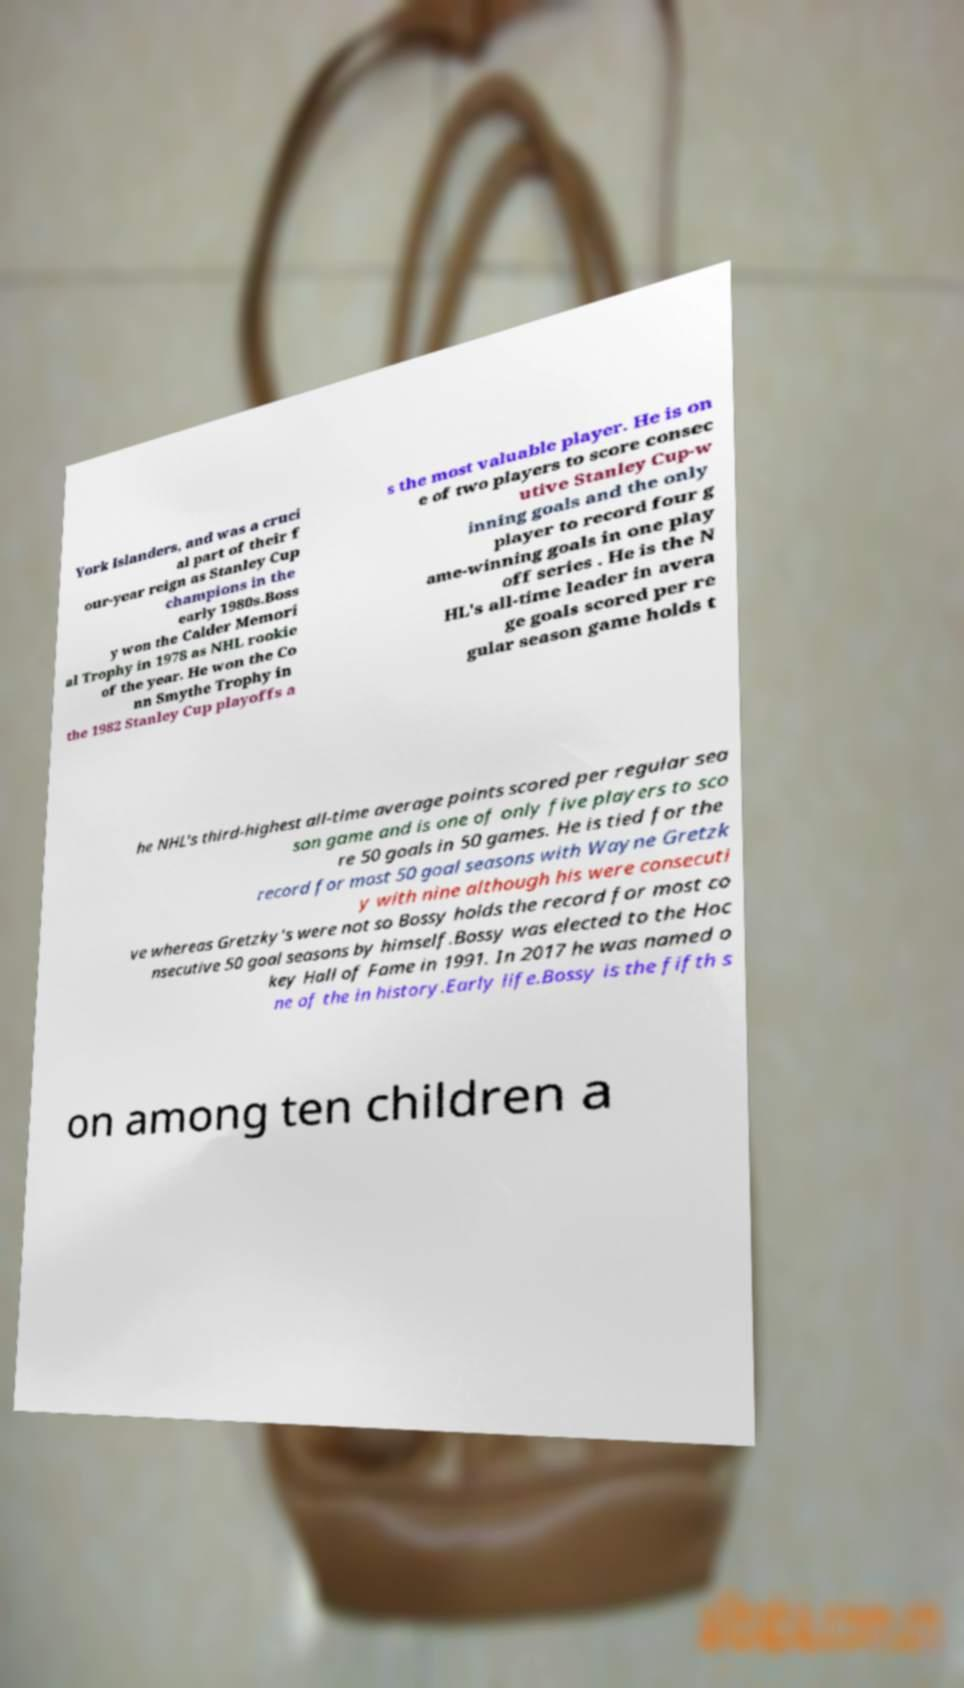Could you assist in decoding the text presented in this image and type it out clearly? York Islanders, and was a cruci al part of their f our-year reign as Stanley Cup champions in the early 1980s.Boss y won the Calder Memori al Trophy in 1978 as NHL rookie of the year. He won the Co nn Smythe Trophy in the 1982 Stanley Cup playoffs a s the most valuable player. He is on e of two players to score consec utive Stanley Cup-w inning goals and the only player to record four g ame-winning goals in one play off series . He is the N HL's all-time leader in avera ge goals scored per re gular season game holds t he NHL's third-highest all-time average points scored per regular sea son game and is one of only five players to sco re 50 goals in 50 games. He is tied for the record for most 50 goal seasons with Wayne Gretzk y with nine although his were consecuti ve whereas Gretzky's were not so Bossy holds the record for most co nsecutive 50 goal seasons by himself.Bossy was elected to the Hoc key Hall of Fame in 1991. In 2017 he was named o ne of the in history.Early life.Bossy is the fifth s on among ten children a 